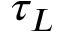<formula> <loc_0><loc_0><loc_500><loc_500>\tau _ { L }</formula> 